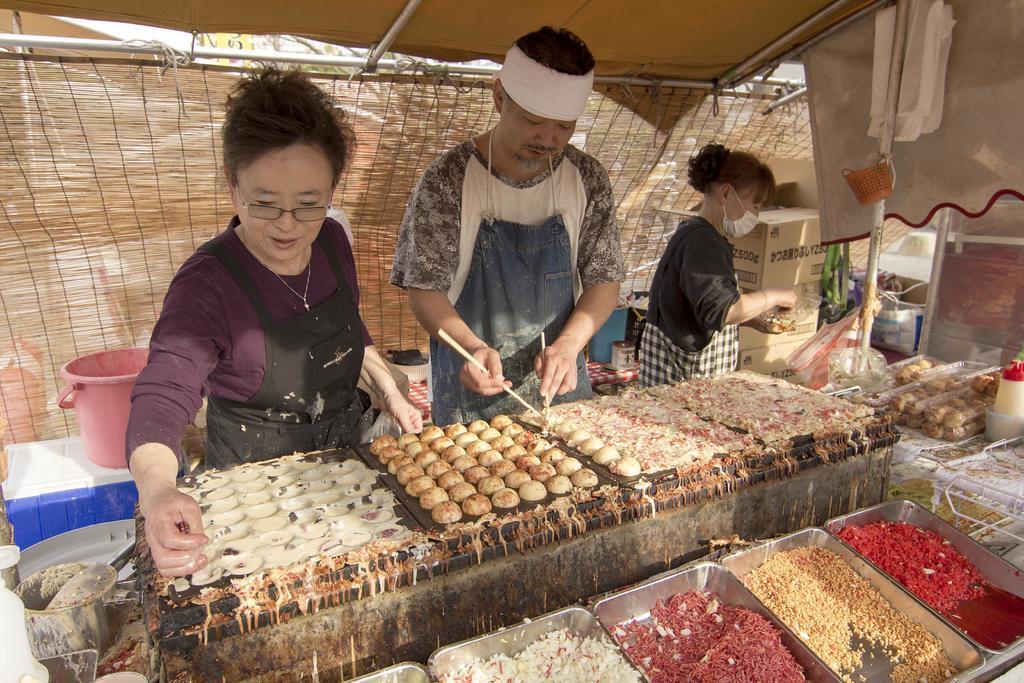In one or two sentences, can you explain what this image depicts? Here in this picture we can see three people standing over a place and two persons are trying to cook food on the stove present in front of them over there and the other person is trying to mix something in the bowl, as we can see she is wearing a mask on her and above them we can see a tent present and behind them also we can see the tent covered and we can see all the things present in the trays in front of them and we can also see other boxes and glasses and all other things present beside them all over there. 